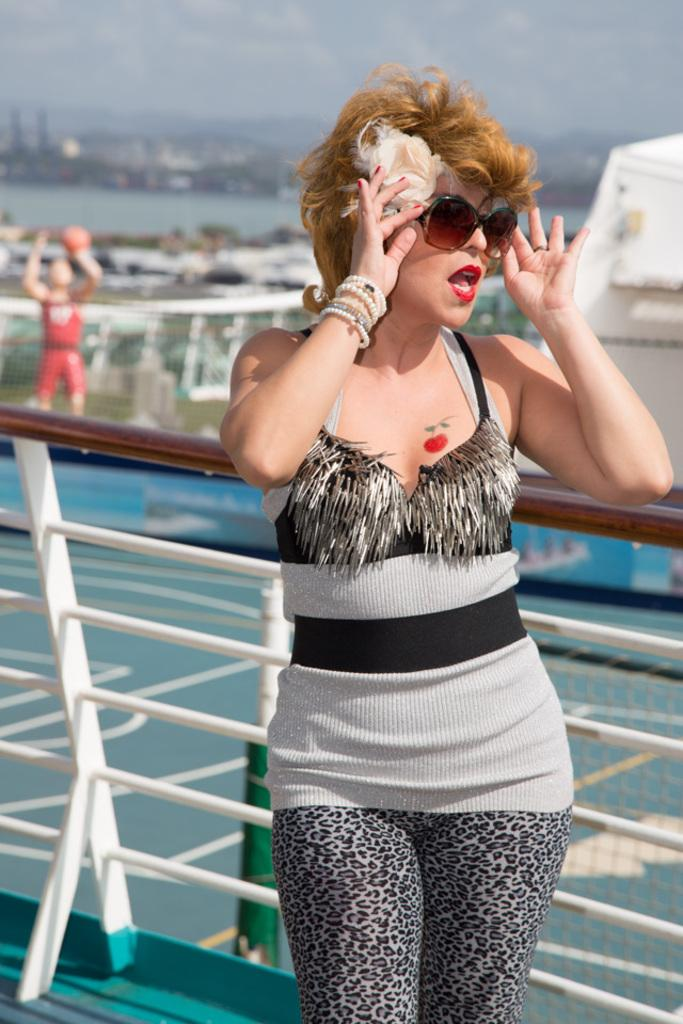Who is present in the picture? There is a woman in the picture. Where is the woman located? The woman is standing inside a ship. What is the woman doing in the picture? The woman is posing for a photo. What can be seen in the background of the picture? There are other boats and ships visible in the water behind the woman. What type of shoes is the ghost wearing in the image? There is no ghost present in the image, so it is not possible to determine what type of shoes the ghost might be wearing. 